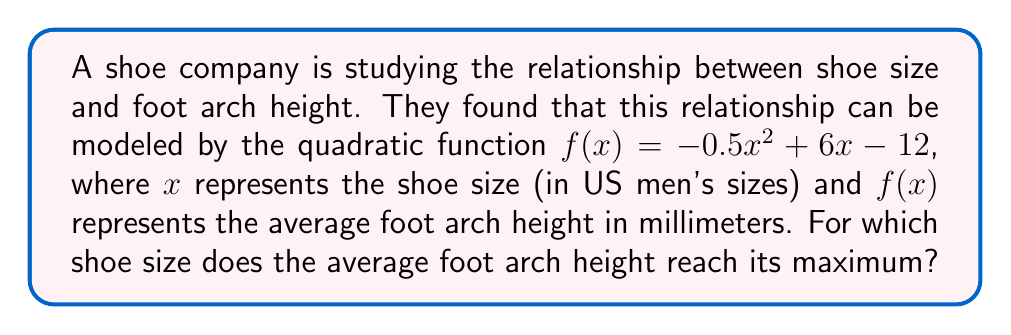What is the answer to this math problem? To find the shoe size at which the average foot arch height reaches its maximum, we need to find the vertex of the parabola represented by the quadratic function. The vertex represents the highest point of the parabola.

For a quadratic function in the form $f(x) = ax^2 + bx + c$, the x-coordinate of the vertex is given by $x = -\frac{b}{2a}$.

In this case:
$a = -0.5$
$b = 6$
$c = -12$

Let's calculate the x-coordinate of the vertex:

$$x = -\frac{b}{2a} = -\frac{6}{2(-0.5)} = -\frac{6}{-1} = 6$$

Therefore, the average foot arch height reaches its maximum at a shoe size of 6 (US men's size).

To verify this, we can calculate $f(x)$ for values slightly less than and greater than 6:

$f(5.9) = -0.5(5.9)^2 + 6(5.9) - 12 \approx 5.9855$
$f(6) = -0.5(6)^2 + 6(6) - 12 = 6$
$f(6.1) = -0.5(6.1)^2 + 6(6.1) - 12 \approx 5.9955$

As we can see, $f(6)$ gives the highest value, confirming our answer.
Answer: The average foot arch height reaches its maximum at a shoe size of 6 (US men's size). 